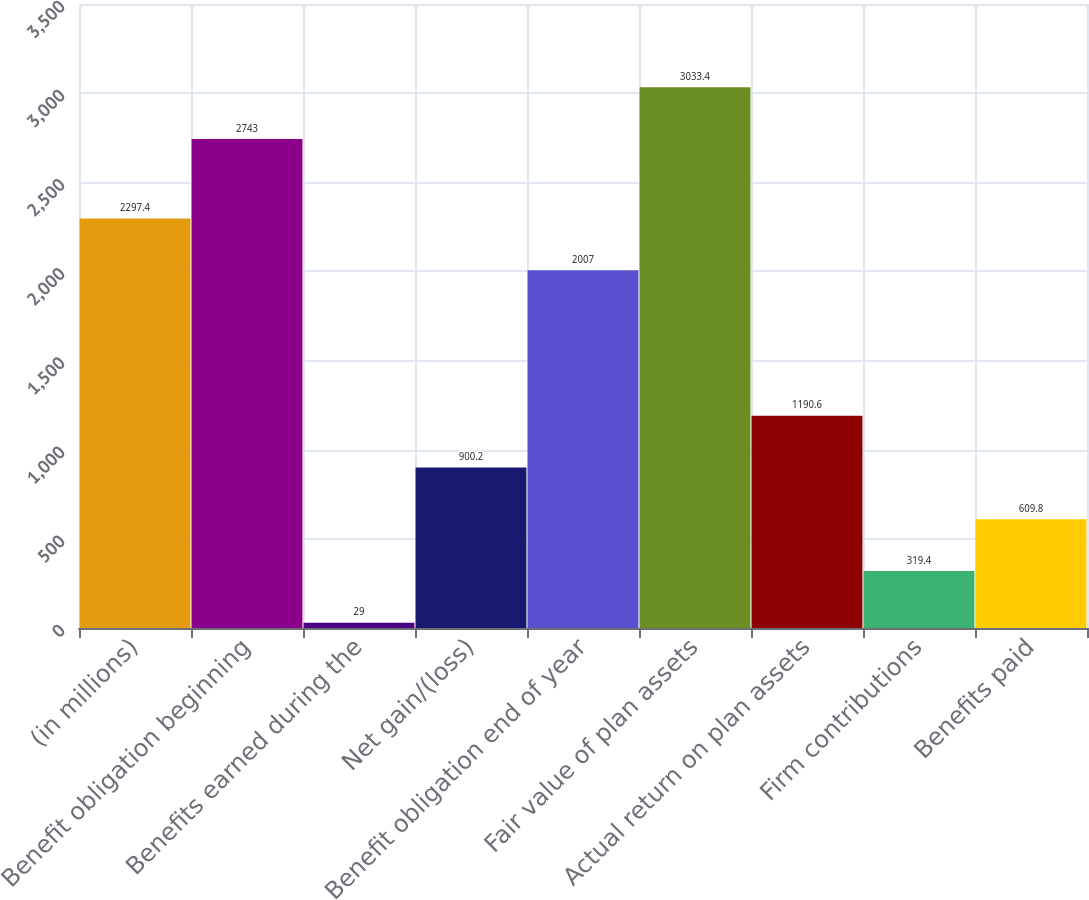<chart> <loc_0><loc_0><loc_500><loc_500><bar_chart><fcel>(in millions)<fcel>Benefit obligation beginning<fcel>Benefits earned during the<fcel>Net gain/(loss)<fcel>Benefit obligation end of year<fcel>Fair value of plan assets<fcel>Actual return on plan assets<fcel>Firm contributions<fcel>Benefits paid<nl><fcel>2297.4<fcel>2743<fcel>29<fcel>900.2<fcel>2007<fcel>3033.4<fcel>1190.6<fcel>319.4<fcel>609.8<nl></chart> 